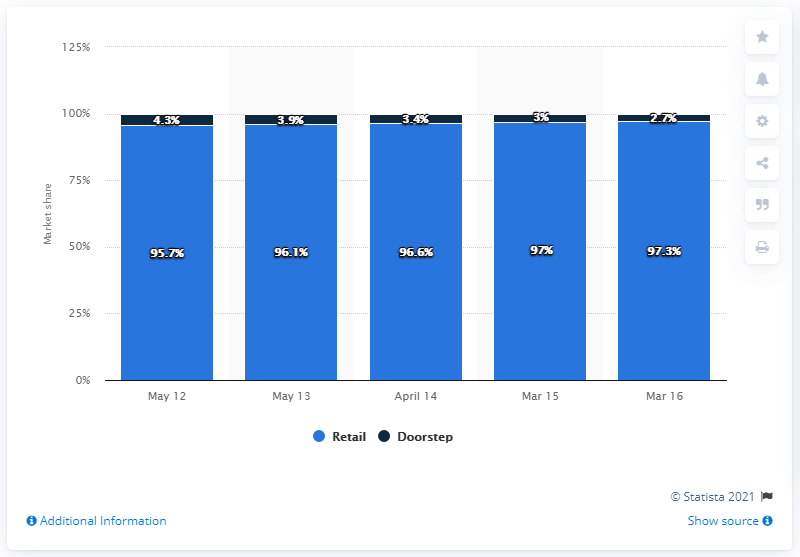Indicate a few pertinent items in this graphic. In the year ending March 2016, milk deliveries made up 2.7% of the total retail volume share. 